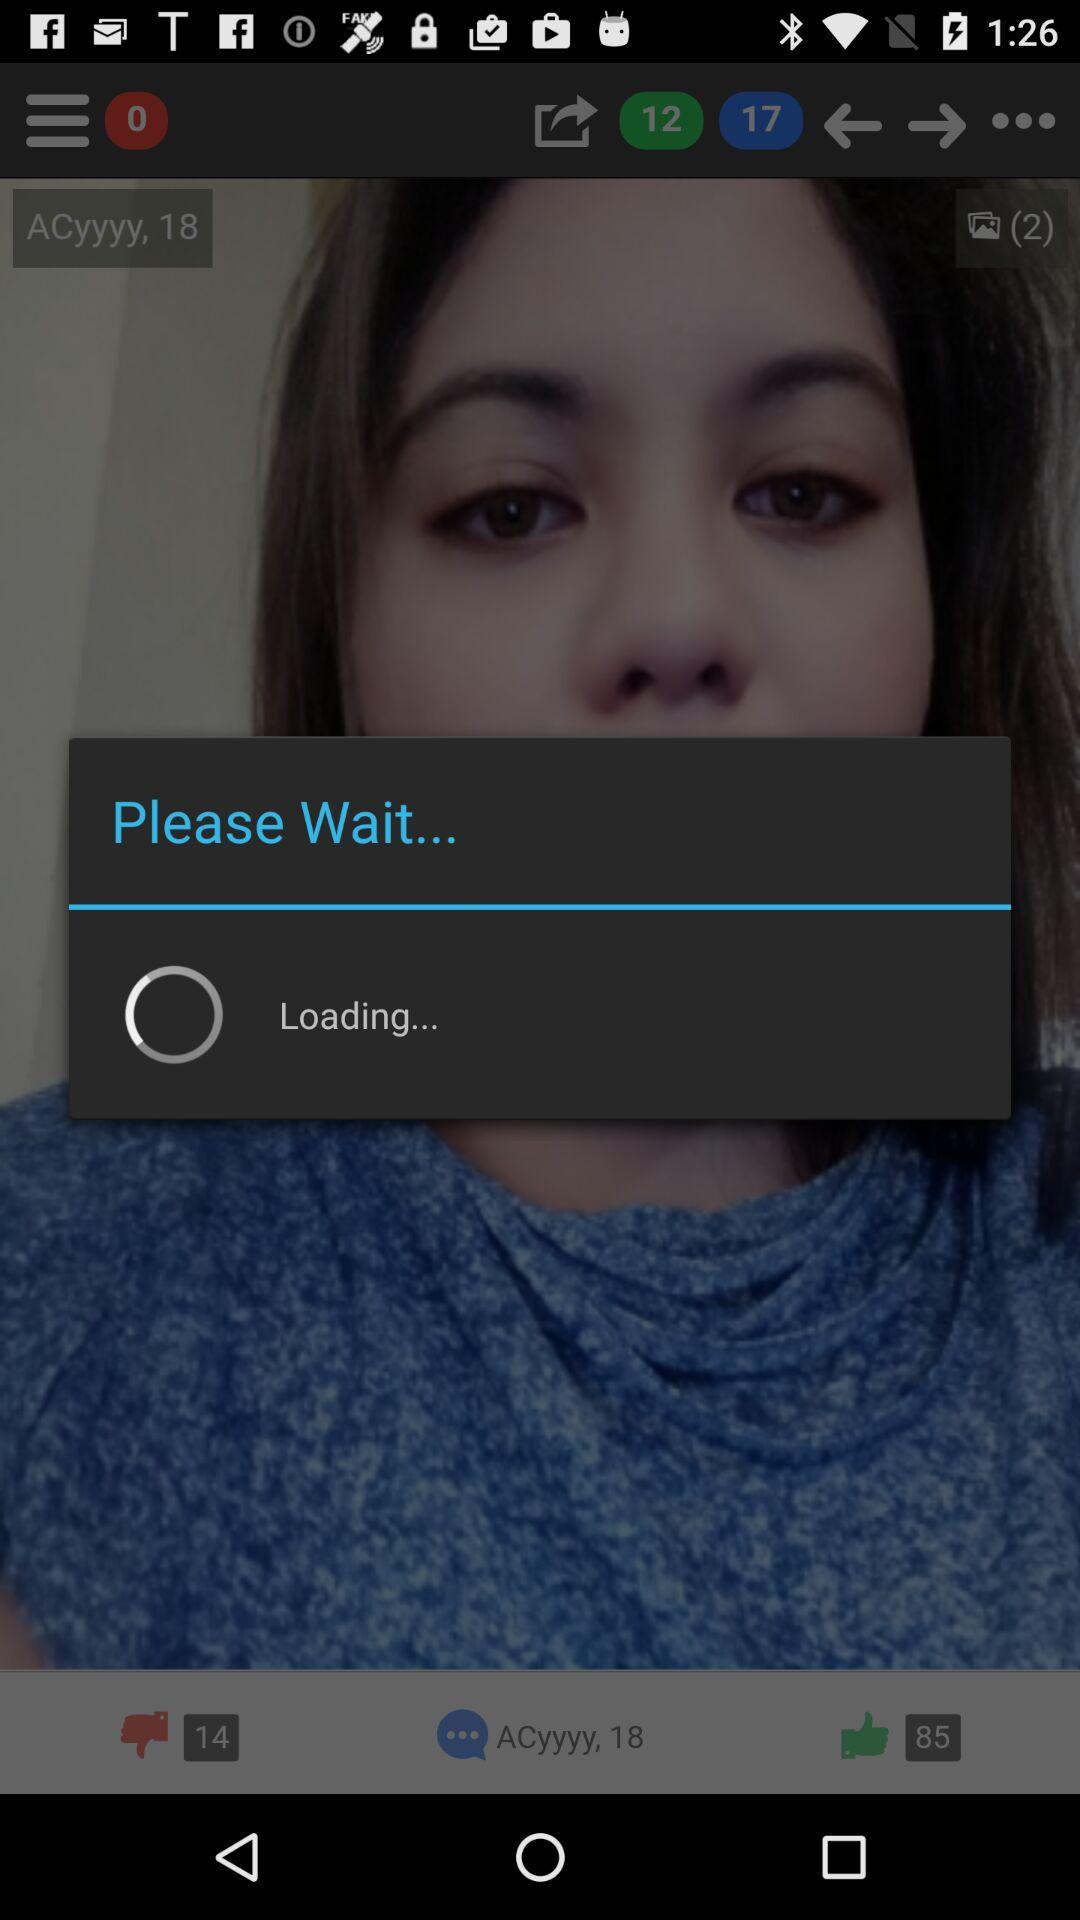What is the user name? The user name is Jon. 